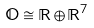Convert formula to latex. <formula><loc_0><loc_0><loc_500><loc_500>\mathbb { O } \cong \mathbb { R } \oplus \mathbb { R } ^ { 7 }</formula> 